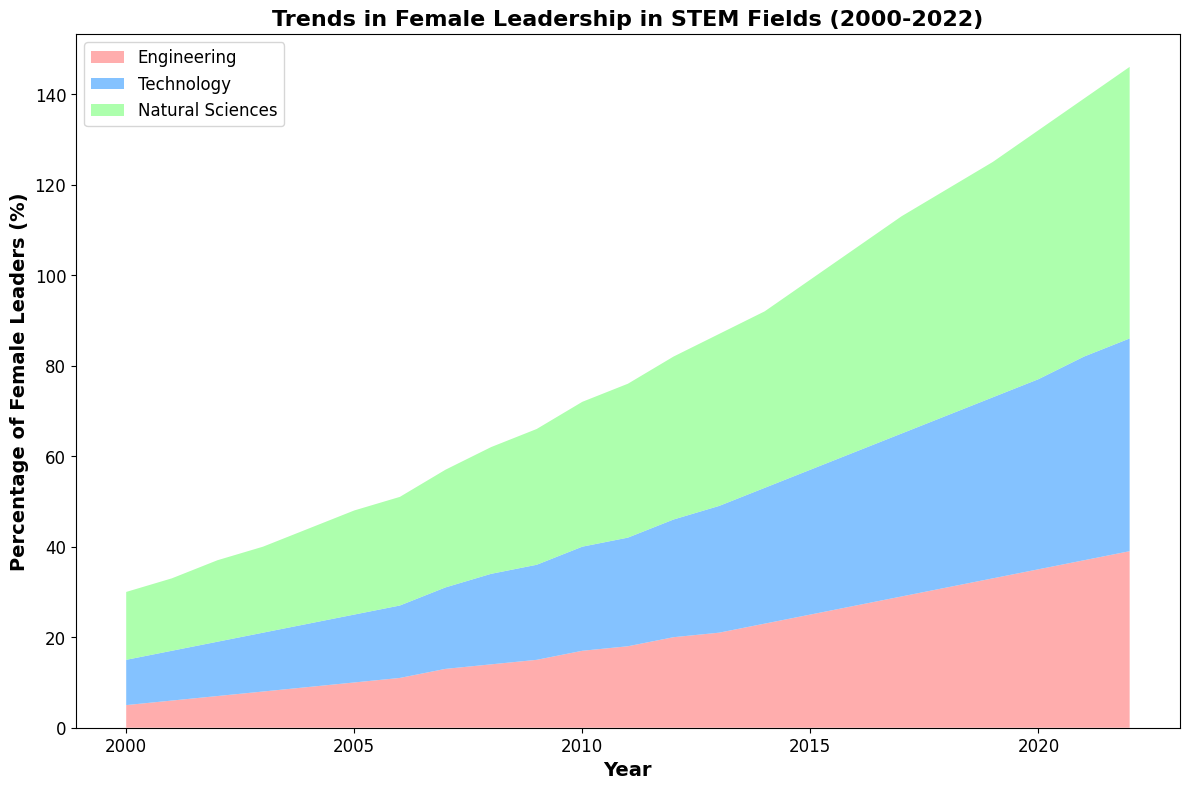How does the percentage of female leaders in Natural Sciences change from 2000 to 2022? To determine the change, subtract the percentage in 2000 from the percentage in 2022. From the chart, in 2000, it is 15%, and in 2022, it is 60%. Thus, the change is 60% - 15% = 45%.
Answer: 45% In which year did the percentage of female leaders in Engineering first surpass that in Technology? By observing the chart, compare the areas for Engineering and Technology over the years. In 2013, the percentage for Engineering (21%) surpasses Technology (20%).
Answer: 2013 What is the combined percentage of female leaders in Engineering and Technology in 2010? Add the percentages of female leaders in Engineering (17%) and Technology (23%) for the year 2010. The combined percentage is 17% + 23% = 40%.
Answer: 40% In which year did Natural Sciences experience the highest yearly increase in female leadership? Compare the yearly differences in percentages for Natural Sciences. The highest increase is from 2015 (42%) to 2016 (45%), which is an increase of 3%.
Answer: 2016 What is the total percentage of female leaders in all STEM fields in 2020? Sum the percentages of female leaders in Engineering (35%), Technology (42%), and Natural Sciences (55%) for the year 2020. The total is 35% + 42% + 55% = 132%.
Answer: 132% Between 2010 and 2015, which field saw the largest increase in the percentage of female leaders? Calculate the increase for each field:
- Engineering: 25% - 17% = 8%
- Technology: 32% - 23% = 9%
- Natural Sciences: 42% - 32% = 10%
Natural Sciences experienced the largest increase of 10%.
Answer: Natural Sciences How do the trends in female leadership differ between Engineering and Natural Sciences over the entire period? Compare the overall trends: Engineering shows a steady rise with smaller increments whereas Natural Sciences shows a steeper increase with larger increments.
Answer: Steadier in Engineering, steeper in Natural Sciences In which year did the combined percentage of female leaders in all fields reach 100% for the first time? Observe the stacked areas to identify when their sum first reaches or exceeds 100%. The first year this happens is 2011 with a combined percentage of 18% (E) + 24% (T) + 34% (NS) = 76%. However, the closest to 100% happens around 2018 when the combined percentage is close to 119%.
Answer: 2018 What is the average annual increase in female leadership in Technology from 2000 to 2022? Calculate the total increase over the period and divide by the number of years. The increase is 47% (57% in 2022 - 10% in 2000) over 22 years, so the average annual increase is 47% / 22 ≈ 2.14%.
Answer: ~2.14% 